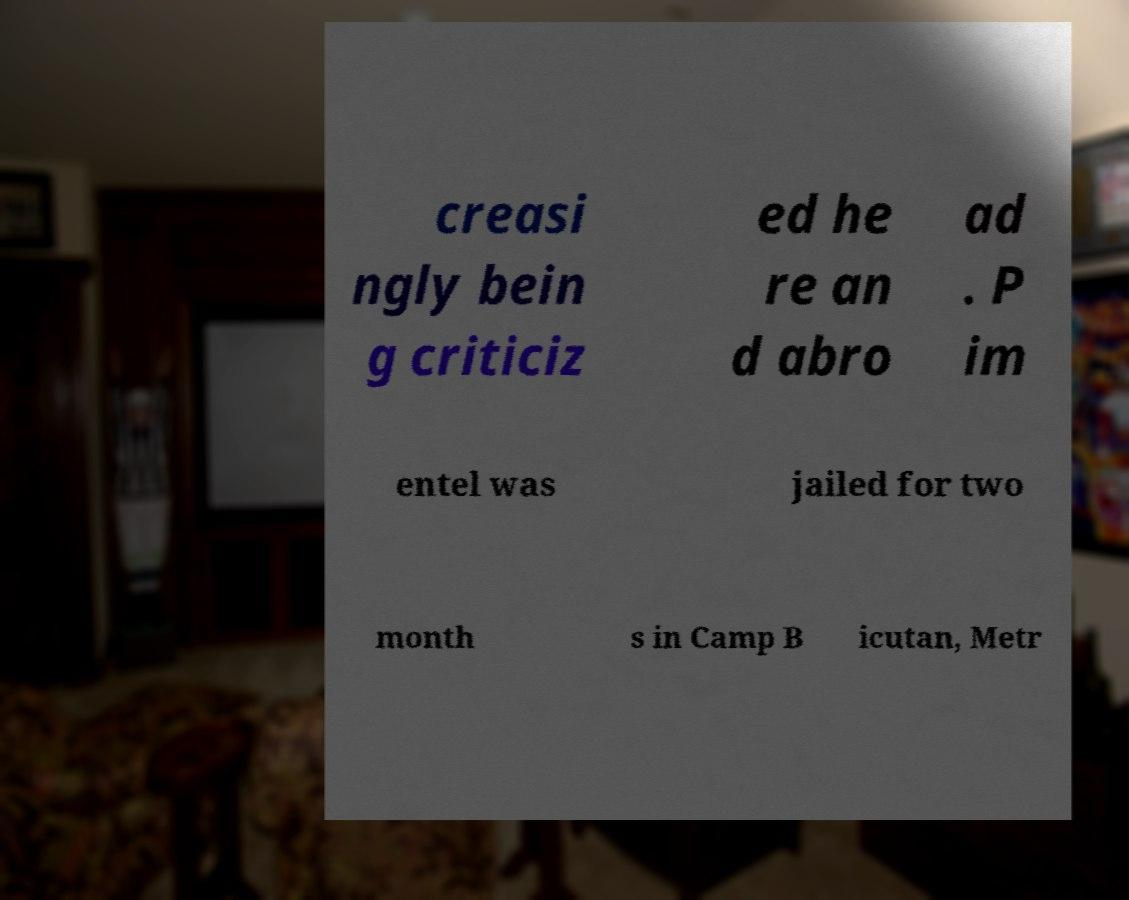Please identify and transcribe the text found in this image. creasi ngly bein g criticiz ed he re an d abro ad . P im entel was jailed for two month s in Camp B icutan, Metr 